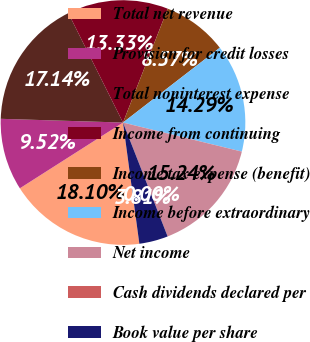Convert chart to OTSL. <chart><loc_0><loc_0><loc_500><loc_500><pie_chart><fcel>Total net revenue<fcel>Provision for credit losses<fcel>Total noninterest expense<fcel>Income from continuing<fcel>Income tax expense (benefit)<fcel>Income before extraordinary<fcel>Net income<fcel>Cash dividends declared per<fcel>Book value per share<nl><fcel>18.1%<fcel>9.52%<fcel>17.14%<fcel>13.33%<fcel>8.57%<fcel>14.29%<fcel>15.24%<fcel>0.0%<fcel>3.81%<nl></chart> 